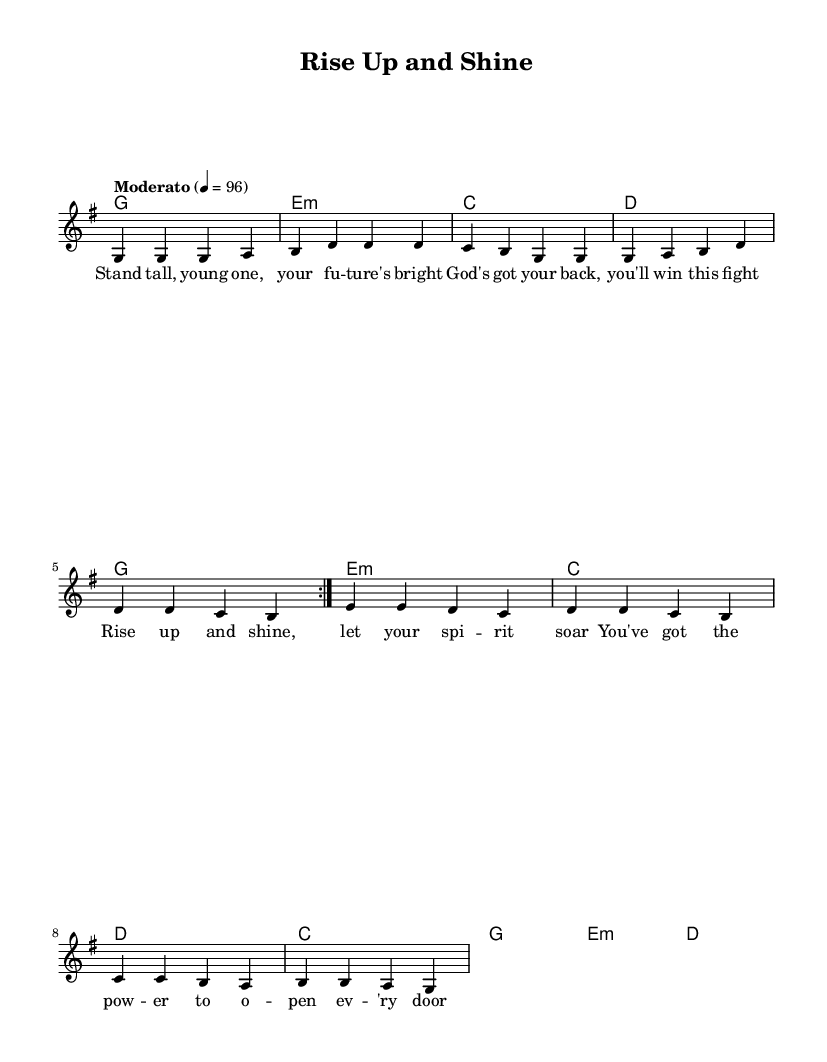What is the key signature of this music? The key signature is G major, which has one sharp (F#). This can be determined by looking at the key signature notation placed at the beginning of the staff.
Answer: G major What is the time signature of this music? The time signature is 4/4, which can be identified at the beginning of the music. It indicates that there are four beats in each measure and the quarter note receives one beat.
Answer: 4/4 What is the tempo marking for this piece? The tempo marking states "Moderato" with a metronome indication of quarter note equals 96. This means the music should be played at a moderately fast pace.
Answer: Moderato How many measures are in the repeated section? The repeated section is indicated by "volta 2" and consists of eight measures (four measures per repeat times two). This means the music is designed to be played twice in total for that section.
Answer: Eight measures What is the main message conveyed in the lyrics? The lyrics focus on empowerment and trust in God, as they encourage young individuals to be strong and believe in their potential. The phrases highlight positivity and motivation, forming a core message of resilience.
Answer: Empowerment What type of accompaniment is indicated in the music? The accompaniment consists of chord symbols written above the melody, which indicates that the musicians should play harmonies in the background following the specified chords in the harmonic sequence.
Answer: Chord symbols What is the overall theme of the song? The overall theme revolves around youth empowerment through faith, encouraging the youth to rise up and shine while trusting in God's support. This aligns with the religious context of the piece.
Answer: Youth empowerment 